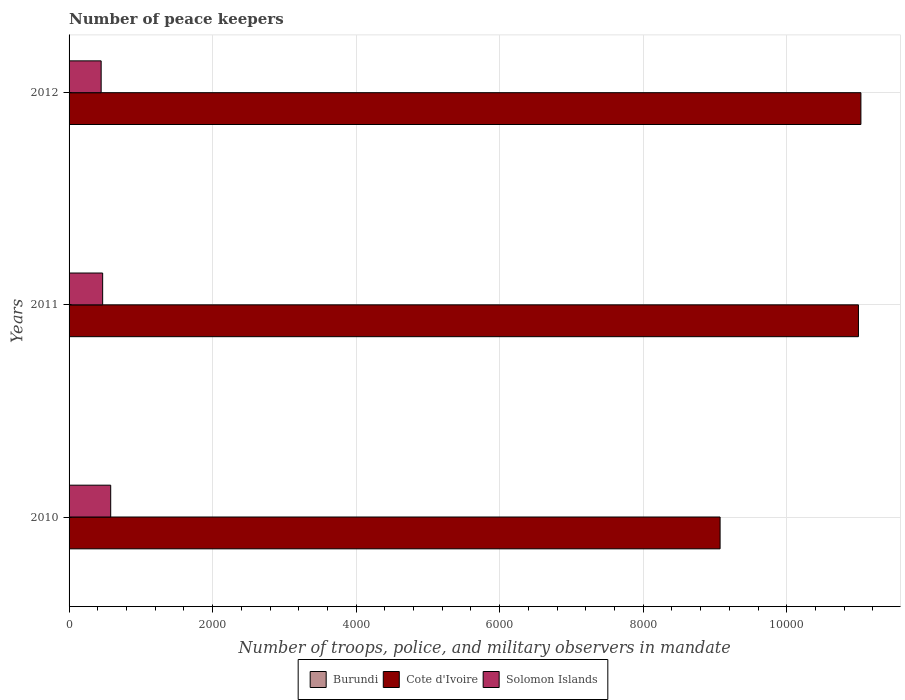How many different coloured bars are there?
Give a very brief answer. 3. What is the label of the 2nd group of bars from the top?
Make the answer very short. 2011. In how many cases, is the number of bars for a given year not equal to the number of legend labels?
Give a very brief answer. 0. What is the number of peace keepers in in Cote d'Ivoire in 2011?
Your response must be concise. 1.10e+04. Across all years, what is the maximum number of peace keepers in in Burundi?
Keep it short and to the point. 4. Across all years, what is the minimum number of peace keepers in in Solomon Islands?
Your response must be concise. 447. In which year was the number of peace keepers in in Cote d'Ivoire maximum?
Keep it short and to the point. 2012. What is the total number of peace keepers in in Cote d'Ivoire in the graph?
Keep it short and to the point. 3.11e+04. What is the difference between the number of peace keepers in in Solomon Islands in 2011 and that in 2012?
Provide a succinct answer. 21. What is the difference between the number of peace keepers in in Solomon Islands in 2010 and the number of peace keepers in in Cote d'Ivoire in 2012?
Your response must be concise. -1.05e+04. What is the average number of peace keepers in in Burundi per year?
Your answer should be compact. 2.33. In the year 2010, what is the difference between the number of peace keepers in in Burundi and number of peace keepers in in Cote d'Ivoire?
Offer a terse response. -9067. What is the ratio of the number of peace keepers in in Cote d'Ivoire in 2010 to that in 2012?
Provide a short and direct response. 0.82. What is the difference between the highest and the lowest number of peace keepers in in Solomon Islands?
Your answer should be very brief. 133. In how many years, is the number of peace keepers in in Solomon Islands greater than the average number of peace keepers in in Solomon Islands taken over all years?
Your answer should be very brief. 1. Is the sum of the number of peace keepers in in Burundi in 2010 and 2012 greater than the maximum number of peace keepers in in Solomon Islands across all years?
Your answer should be very brief. No. What does the 3rd bar from the top in 2012 represents?
Your answer should be very brief. Burundi. What does the 2nd bar from the bottom in 2012 represents?
Your answer should be very brief. Cote d'Ivoire. Is it the case that in every year, the sum of the number of peace keepers in in Burundi and number of peace keepers in in Cote d'Ivoire is greater than the number of peace keepers in in Solomon Islands?
Keep it short and to the point. Yes. Are all the bars in the graph horizontal?
Keep it short and to the point. Yes. What is the difference between two consecutive major ticks on the X-axis?
Your answer should be very brief. 2000. Does the graph contain any zero values?
Provide a succinct answer. No. How are the legend labels stacked?
Offer a terse response. Horizontal. What is the title of the graph?
Give a very brief answer. Number of peace keepers. What is the label or title of the X-axis?
Your response must be concise. Number of troops, police, and military observers in mandate. What is the Number of troops, police, and military observers in mandate of Cote d'Ivoire in 2010?
Give a very brief answer. 9071. What is the Number of troops, police, and military observers in mandate in Solomon Islands in 2010?
Ensure brevity in your answer.  580. What is the Number of troops, police, and military observers in mandate in Burundi in 2011?
Provide a succinct answer. 1. What is the Number of troops, police, and military observers in mandate in Cote d'Ivoire in 2011?
Keep it short and to the point. 1.10e+04. What is the Number of troops, police, and military observers in mandate in Solomon Islands in 2011?
Your answer should be compact. 468. What is the Number of troops, police, and military observers in mandate in Cote d'Ivoire in 2012?
Ensure brevity in your answer.  1.10e+04. What is the Number of troops, police, and military observers in mandate of Solomon Islands in 2012?
Offer a very short reply. 447. Across all years, what is the maximum Number of troops, police, and military observers in mandate of Cote d'Ivoire?
Your answer should be very brief. 1.10e+04. Across all years, what is the maximum Number of troops, police, and military observers in mandate of Solomon Islands?
Give a very brief answer. 580. Across all years, what is the minimum Number of troops, police, and military observers in mandate in Cote d'Ivoire?
Make the answer very short. 9071. Across all years, what is the minimum Number of troops, police, and military observers in mandate in Solomon Islands?
Your answer should be very brief. 447. What is the total Number of troops, police, and military observers in mandate of Cote d'Ivoire in the graph?
Provide a short and direct response. 3.11e+04. What is the total Number of troops, police, and military observers in mandate in Solomon Islands in the graph?
Offer a very short reply. 1495. What is the difference between the Number of troops, police, and military observers in mandate in Burundi in 2010 and that in 2011?
Keep it short and to the point. 3. What is the difference between the Number of troops, police, and military observers in mandate of Cote d'Ivoire in 2010 and that in 2011?
Offer a very short reply. -1928. What is the difference between the Number of troops, police, and military observers in mandate in Solomon Islands in 2010 and that in 2011?
Provide a succinct answer. 112. What is the difference between the Number of troops, police, and military observers in mandate of Burundi in 2010 and that in 2012?
Ensure brevity in your answer.  2. What is the difference between the Number of troops, police, and military observers in mandate of Cote d'Ivoire in 2010 and that in 2012?
Provide a short and direct response. -1962. What is the difference between the Number of troops, police, and military observers in mandate of Solomon Islands in 2010 and that in 2012?
Provide a succinct answer. 133. What is the difference between the Number of troops, police, and military observers in mandate in Cote d'Ivoire in 2011 and that in 2012?
Your answer should be very brief. -34. What is the difference between the Number of troops, police, and military observers in mandate in Burundi in 2010 and the Number of troops, police, and military observers in mandate in Cote d'Ivoire in 2011?
Your answer should be very brief. -1.10e+04. What is the difference between the Number of troops, police, and military observers in mandate in Burundi in 2010 and the Number of troops, police, and military observers in mandate in Solomon Islands in 2011?
Offer a terse response. -464. What is the difference between the Number of troops, police, and military observers in mandate in Cote d'Ivoire in 2010 and the Number of troops, police, and military observers in mandate in Solomon Islands in 2011?
Your answer should be very brief. 8603. What is the difference between the Number of troops, police, and military observers in mandate of Burundi in 2010 and the Number of troops, police, and military observers in mandate of Cote d'Ivoire in 2012?
Your answer should be very brief. -1.10e+04. What is the difference between the Number of troops, police, and military observers in mandate in Burundi in 2010 and the Number of troops, police, and military observers in mandate in Solomon Islands in 2012?
Offer a terse response. -443. What is the difference between the Number of troops, police, and military observers in mandate of Cote d'Ivoire in 2010 and the Number of troops, police, and military observers in mandate of Solomon Islands in 2012?
Offer a very short reply. 8624. What is the difference between the Number of troops, police, and military observers in mandate in Burundi in 2011 and the Number of troops, police, and military observers in mandate in Cote d'Ivoire in 2012?
Ensure brevity in your answer.  -1.10e+04. What is the difference between the Number of troops, police, and military observers in mandate of Burundi in 2011 and the Number of troops, police, and military observers in mandate of Solomon Islands in 2012?
Provide a succinct answer. -446. What is the difference between the Number of troops, police, and military observers in mandate in Cote d'Ivoire in 2011 and the Number of troops, police, and military observers in mandate in Solomon Islands in 2012?
Make the answer very short. 1.06e+04. What is the average Number of troops, police, and military observers in mandate in Burundi per year?
Keep it short and to the point. 2.33. What is the average Number of troops, police, and military observers in mandate of Cote d'Ivoire per year?
Your answer should be compact. 1.04e+04. What is the average Number of troops, police, and military observers in mandate in Solomon Islands per year?
Provide a short and direct response. 498.33. In the year 2010, what is the difference between the Number of troops, police, and military observers in mandate of Burundi and Number of troops, police, and military observers in mandate of Cote d'Ivoire?
Your response must be concise. -9067. In the year 2010, what is the difference between the Number of troops, police, and military observers in mandate of Burundi and Number of troops, police, and military observers in mandate of Solomon Islands?
Offer a terse response. -576. In the year 2010, what is the difference between the Number of troops, police, and military observers in mandate in Cote d'Ivoire and Number of troops, police, and military observers in mandate in Solomon Islands?
Offer a terse response. 8491. In the year 2011, what is the difference between the Number of troops, police, and military observers in mandate of Burundi and Number of troops, police, and military observers in mandate of Cote d'Ivoire?
Ensure brevity in your answer.  -1.10e+04. In the year 2011, what is the difference between the Number of troops, police, and military observers in mandate in Burundi and Number of troops, police, and military observers in mandate in Solomon Islands?
Keep it short and to the point. -467. In the year 2011, what is the difference between the Number of troops, police, and military observers in mandate of Cote d'Ivoire and Number of troops, police, and military observers in mandate of Solomon Islands?
Your response must be concise. 1.05e+04. In the year 2012, what is the difference between the Number of troops, police, and military observers in mandate in Burundi and Number of troops, police, and military observers in mandate in Cote d'Ivoire?
Offer a terse response. -1.10e+04. In the year 2012, what is the difference between the Number of troops, police, and military observers in mandate in Burundi and Number of troops, police, and military observers in mandate in Solomon Islands?
Your response must be concise. -445. In the year 2012, what is the difference between the Number of troops, police, and military observers in mandate of Cote d'Ivoire and Number of troops, police, and military observers in mandate of Solomon Islands?
Give a very brief answer. 1.06e+04. What is the ratio of the Number of troops, police, and military observers in mandate in Burundi in 2010 to that in 2011?
Provide a succinct answer. 4. What is the ratio of the Number of troops, police, and military observers in mandate in Cote d'Ivoire in 2010 to that in 2011?
Give a very brief answer. 0.82. What is the ratio of the Number of troops, police, and military observers in mandate in Solomon Islands in 2010 to that in 2011?
Offer a very short reply. 1.24. What is the ratio of the Number of troops, police, and military observers in mandate of Cote d'Ivoire in 2010 to that in 2012?
Your answer should be compact. 0.82. What is the ratio of the Number of troops, police, and military observers in mandate of Solomon Islands in 2010 to that in 2012?
Ensure brevity in your answer.  1.3. What is the ratio of the Number of troops, police, and military observers in mandate of Cote d'Ivoire in 2011 to that in 2012?
Give a very brief answer. 1. What is the ratio of the Number of troops, police, and military observers in mandate of Solomon Islands in 2011 to that in 2012?
Offer a terse response. 1.05. What is the difference between the highest and the second highest Number of troops, police, and military observers in mandate of Burundi?
Make the answer very short. 2. What is the difference between the highest and the second highest Number of troops, police, and military observers in mandate of Solomon Islands?
Keep it short and to the point. 112. What is the difference between the highest and the lowest Number of troops, police, and military observers in mandate of Burundi?
Provide a succinct answer. 3. What is the difference between the highest and the lowest Number of troops, police, and military observers in mandate of Cote d'Ivoire?
Your response must be concise. 1962. What is the difference between the highest and the lowest Number of troops, police, and military observers in mandate of Solomon Islands?
Your answer should be compact. 133. 